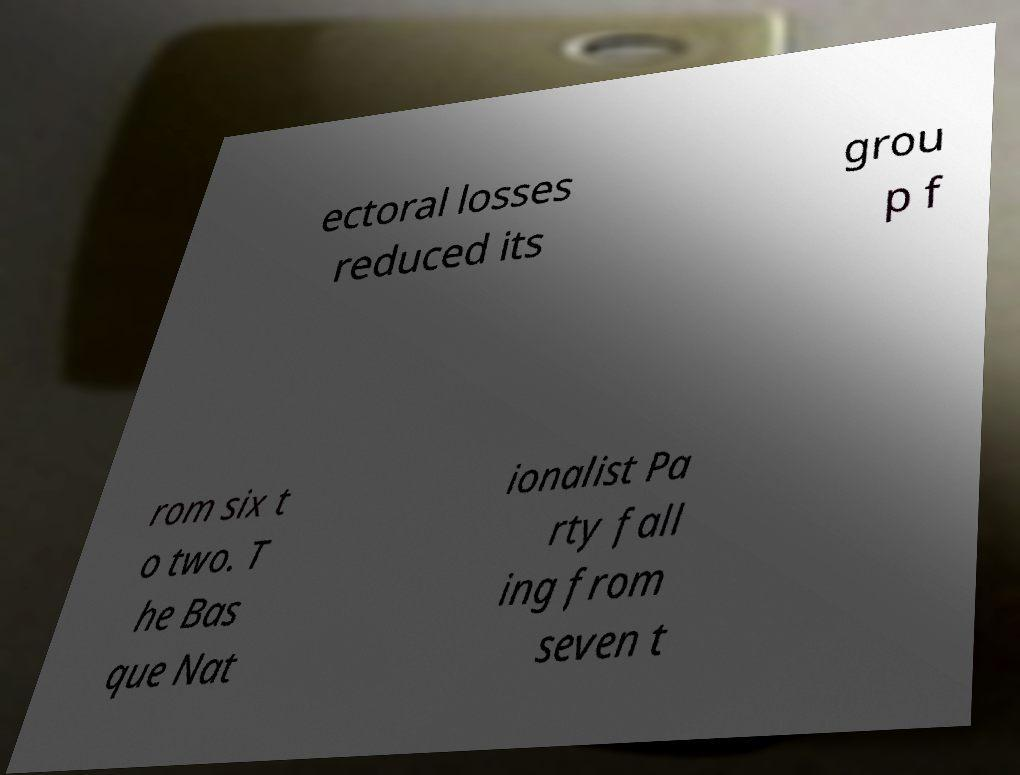For documentation purposes, I need the text within this image transcribed. Could you provide that? ectoral losses reduced its grou p f rom six t o two. T he Bas que Nat ionalist Pa rty fall ing from seven t 